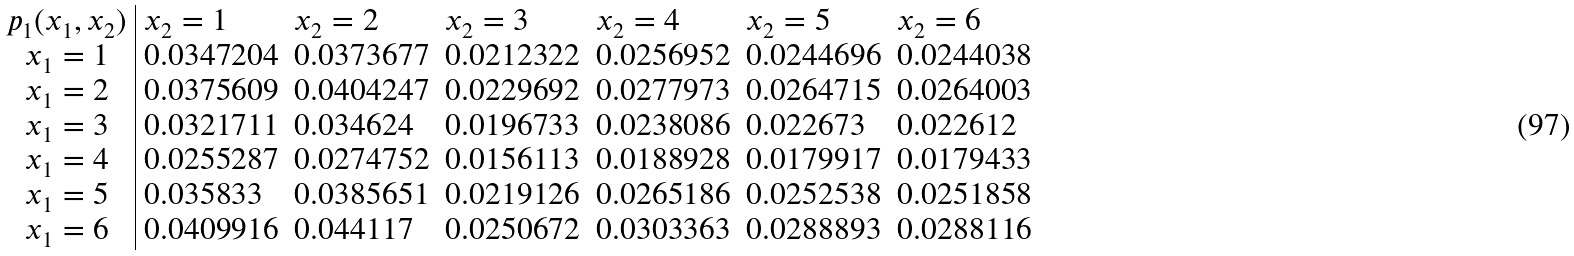<formula> <loc_0><loc_0><loc_500><loc_500>\begin{array} { c | l l l l l l } p _ { 1 } ( x _ { 1 } , x _ { 2 } ) & x _ { 2 } = 1 & x _ { 2 } = 2 & x _ { 2 } = 3 & x _ { 2 } = 4 & x _ { 2 } = 5 & x _ { 2 } = 6 \\ x _ { 1 } = 1 & 0 . 0 3 4 7 2 0 4 & 0 . 0 3 7 3 6 7 7 & 0 . 0 2 1 2 3 2 2 & 0 . 0 2 5 6 9 5 2 & 0 . 0 2 4 4 6 9 6 & 0 . 0 2 4 4 0 3 8 \\ x _ { 1 } = 2 & 0 . 0 3 7 5 6 0 9 & 0 . 0 4 0 4 2 4 7 & 0 . 0 2 2 9 6 9 2 & 0 . 0 2 7 7 9 7 3 & 0 . 0 2 6 4 7 1 5 & 0 . 0 2 6 4 0 0 3 \\ x _ { 1 } = 3 & 0 . 0 3 2 1 7 1 1 & 0 . 0 3 4 6 2 4 & 0 . 0 1 9 6 7 3 3 & 0 . 0 2 3 8 0 8 6 & 0 . 0 2 2 6 7 3 & 0 . 0 2 2 6 1 2 \\ x _ { 1 } = 4 & 0 . 0 2 5 5 2 8 7 & 0 . 0 2 7 4 7 5 2 & 0 . 0 1 5 6 1 1 3 & 0 . 0 1 8 8 9 2 8 & 0 . 0 1 7 9 9 1 7 & 0 . 0 1 7 9 4 3 3 \\ x _ { 1 } = 5 & 0 . 0 3 5 8 3 3 & 0 . 0 3 8 5 6 5 1 & 0 . 0 2 1 9 1 2 6 & 0 . 0 2 6 5 1 8 6 & 0 . 0 2 5 2 5 3 8 & 0 . 0 2 5 1 8 5 8 \\ x _ { 1 } = 6 & 0 . 0 4 0 9 9 1 6 & 0 . 0 4 4 1 1 7 & 0 . 0 2 5 0 6 7 2 & 0 . 0 3 0 3 3 6 3 & 0 . 0 2 8 8 8 9 3 & 0 . 0 2 8 8 1 1 6 \\ \end{array}</formula> 